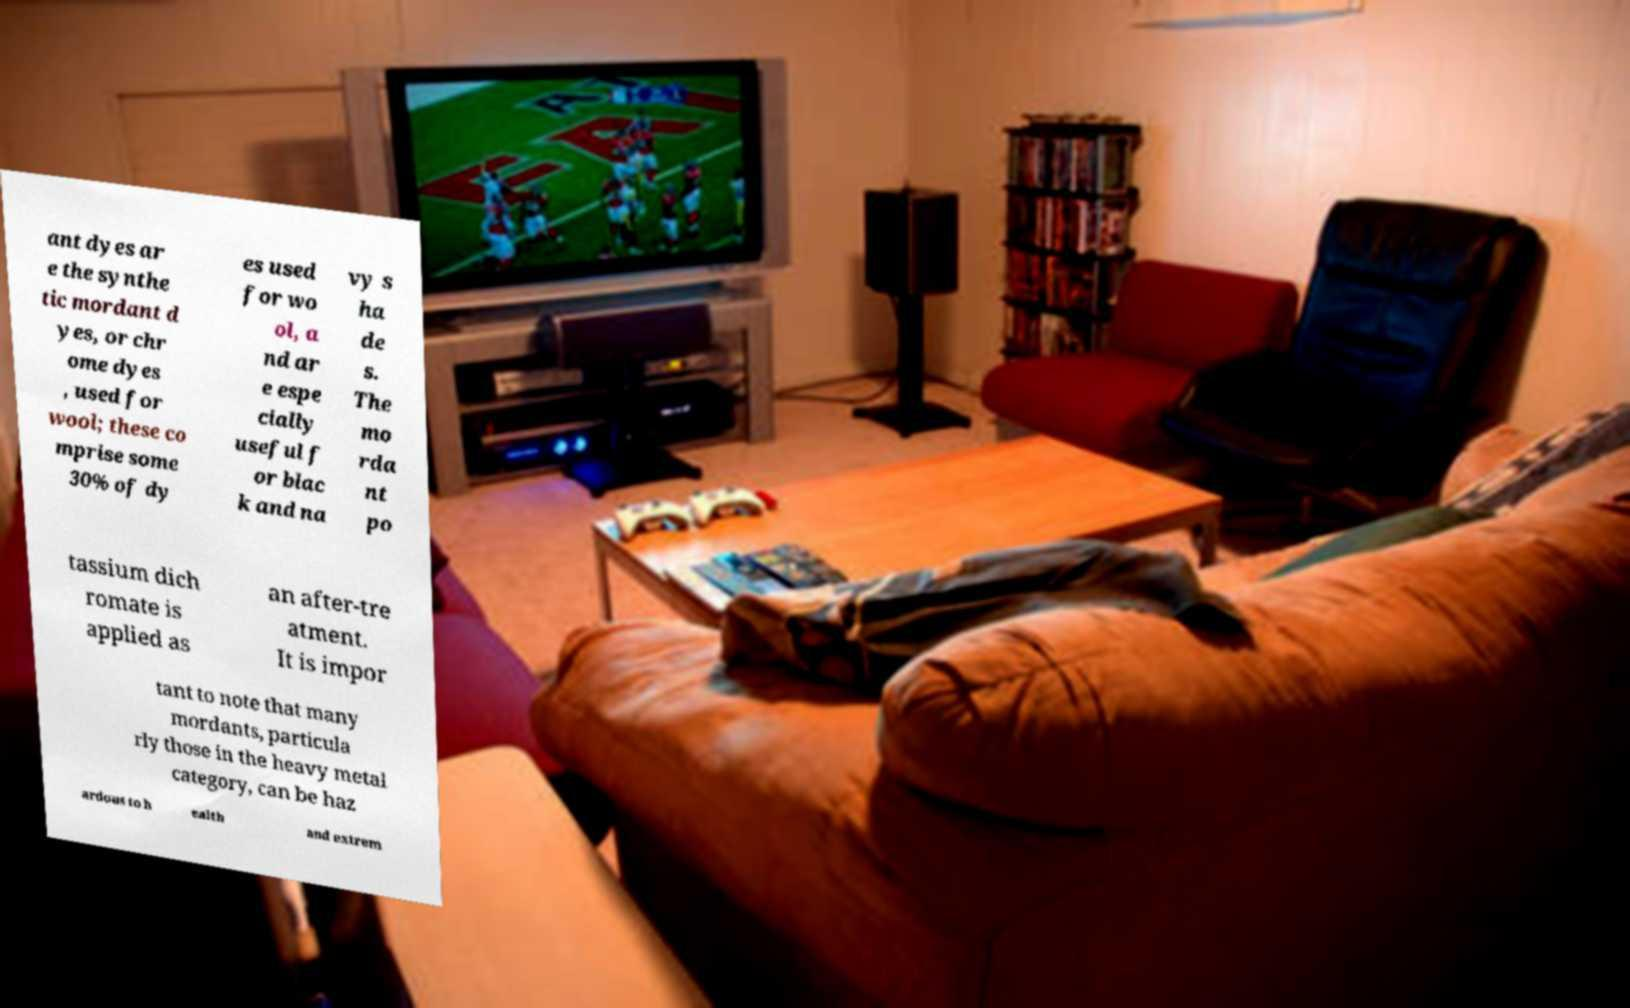I need the written content from this picture converted into text. Can you do that? ant dyes ar e the synthe tic mordant d yes, or chr ome dyes , used for wool; these co mprise some 30% of dy es used for wo ol, a nd ar e espe cially useful f or blac k and na vy s ha de s. The mo rda nt po tassium dich romate is applied as an after-tre atment. It is impor tant to note that many mordants, particula rly those in the heavy metal category, can be haz ardous to h ealth and extrem 